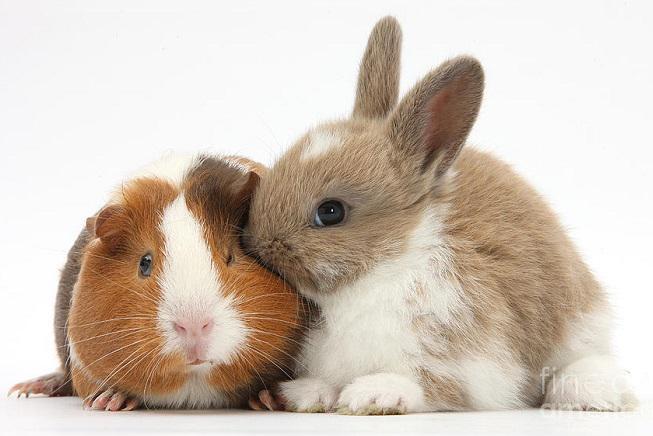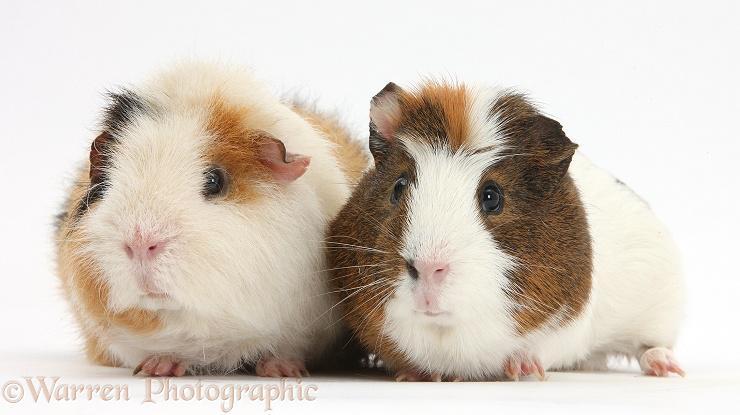The first image is the image on the left, the second image is the image on the right. Given the left and right images, does the statement "A rabbit is posing with the rodent in one of the images." hold true? Answer yes or no. Yes. The first image is the image on the left, the second image is the image on the right. Analyze the images presented: Is the assertion "One image shows a multicolored guinea pig next to a different pet with longer ears." valid? Answer yes or no. Yes. 